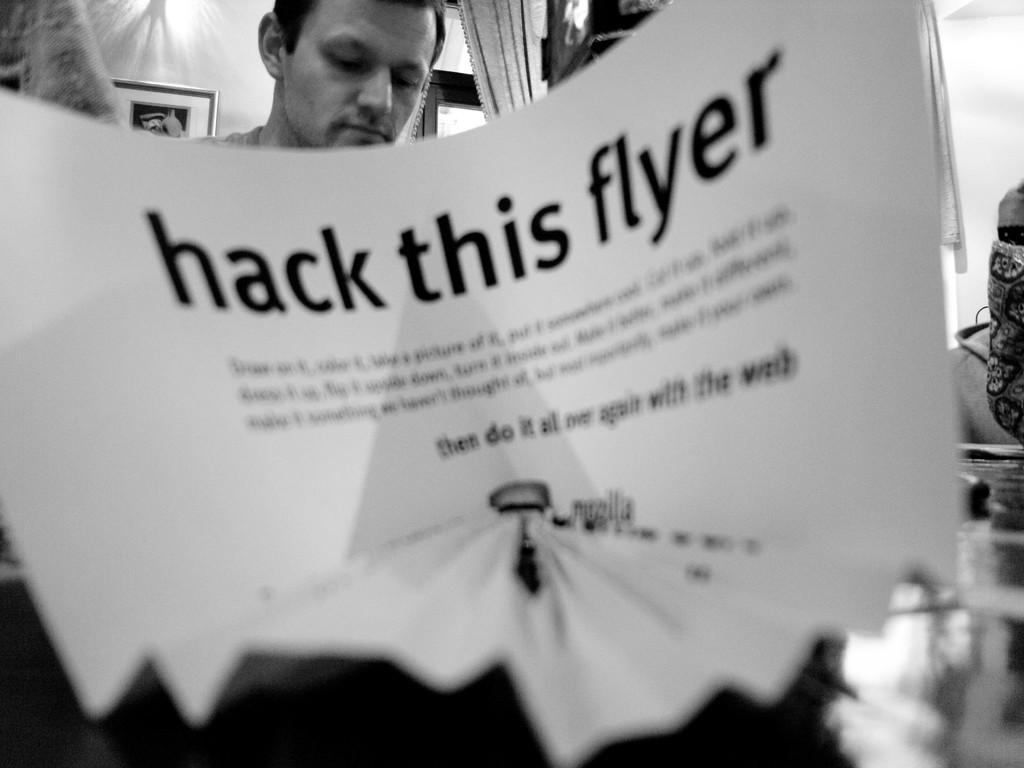What is on the paper that is visible in the image? There is a paper with text in the image. Can you describe the background of the image? There is a man in the background of the image. What object can be seen on the left side of the image? There is a photo frame on the left side of the image. What type of art is the man wearing on his trousers in the image? There is no mention of the man wearing any art on his trousers in the image. 